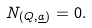Convert formula to latex. <formula><loc_0><loc_0><loc_500><loc_500>N _ { ( Q , \underline { a } ) } = 0 .</formula> 